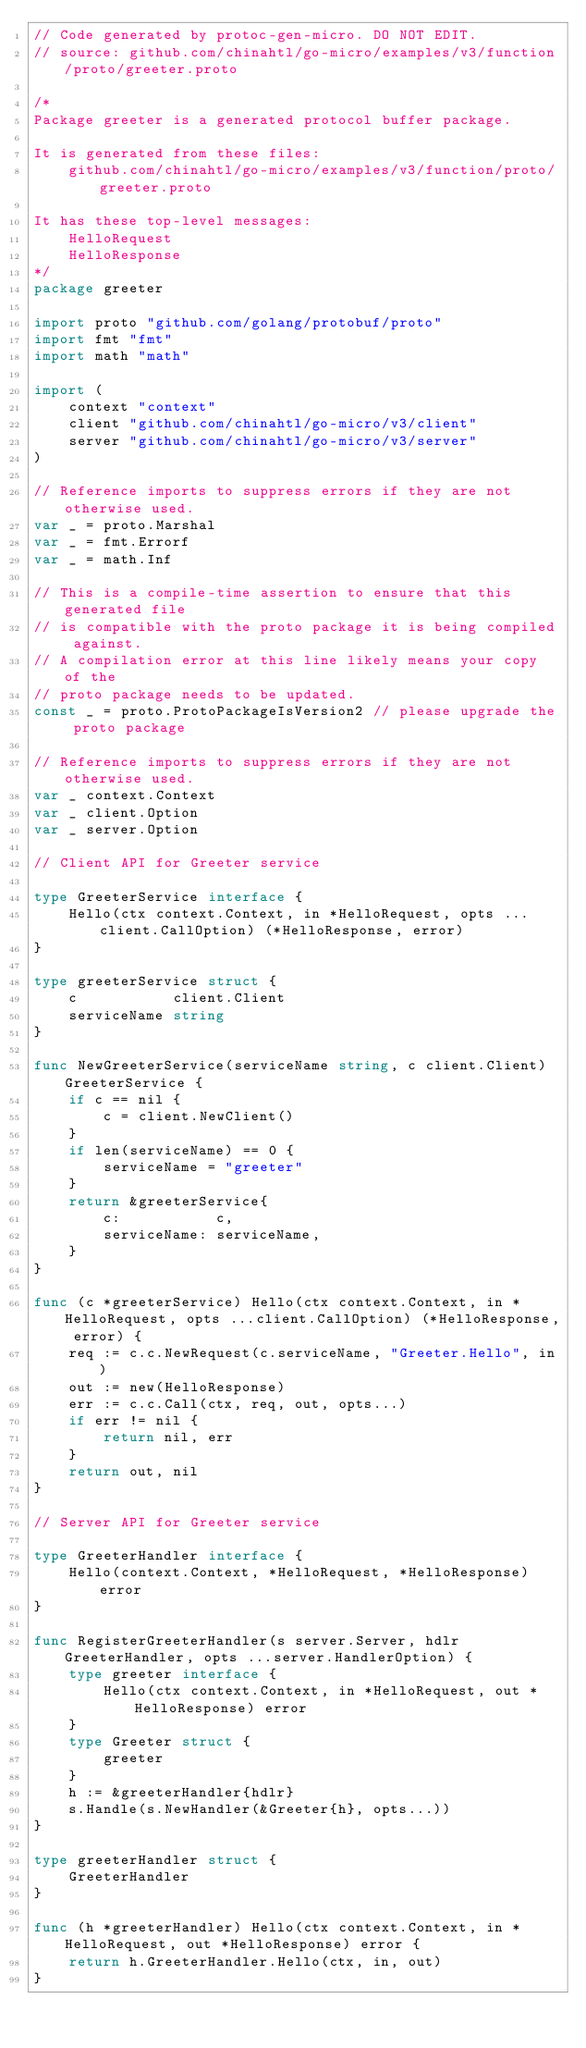Convert code to text. <code><loc_0><loc_0><loc_500><loc_500><_Go_>// Code generated by protoc-gen-micro. DO NOT EDIT.
// source: github.com/chinahtl/go-micro/examples/v3/function/proto/greeter.proto

/*
Package greeter is a generated protocol buffer package.

It is generated from these files:
	github.com/chinahtl/go-micro/examples/v3/function/proto/greeter.proto

It has these top-level messages:
	HelloRequest
	HelloResponse
*/
package greeter

import proto "github.com/golang/protobuf/proto"
import fmt "fmt"
import math "math"

import (
	context "context"
	client "github.com/chinahtl/go-micro/v3/client"
	server "github.com/chinahtl/go-micro/v3/server"
)

// Reference imports to suppress errors if they are not otherwise used.
var _ = proto.Marshal
var _ = fmt.Errorf
var _ = math.Inf

// This is a compile-time assertion to ensure that this generated file
// is compatible with the proto package it is being compiled against.
// A compilation error at this line likely means your copy of the
// proto package needs to be updated.
const _ = proto.ProtoPackageIsVersion2 // please upgrade the proto package

// Reference imports to suppress errors if they are not otherwise used.
var _ context.Context
var _ client.Option
var _ server.Option

// Client API for Greeter service

type GreeterService interface {
	Hello(ctx context.Context, in *HelloRequest, opts ...client.CallOption) (*HelloResponse, error)
}

type greeterService struct {
	c           client.Client
	serviceName string
}

func NewGreeterService(serviceName string, c client.Client) GreeterService {
	if c == nil {
		c = client.NewClient()
	}
	if len(serviceName) == 0 {
		serviceName = "greeter"
	}
	return &greeterService{
		c:           c,
		serviceName: serviceName,
	}
}

func (c *greeterService) Hello(ctx context.Context, in *HelloRequest, opts ...client.CallOption) (*HelloResponse, error) {
	req := c.c.NewRequest(c.serviceName, "Greeter.Hello", in)
	out := new(HelloResponse)
	err := c.c.Call(ctx, req, out, opts...)
	if err != nil {
		return nil, err
	}
	return out, nil
}

// Server API for Greeter service

type GreeterHandler interface {
	Hello(context.Context, *HelloRequest, *HelloResponse) error
}

func RegisterGreeterHandler(s server.Server, hdlr GreeterHandler, opts ...server.HandlerOption) {
	type greeter interface {
		Hello(ctx context.Context, in *HelloRequest, out *HelloResponse) error
	}
	type Greeter struct {
		greeter
	}
	h := &greeterHandler{hdlr}
	s.Handle(s.NewHandler(&Greeter{h}, opts...))
}

type greeterHandler struct {
	GreeterHandler
}

func (h *greeterHandler) Hello(ctx context.Context, in *HelloRequest, out *HelloResponse) error {
	return h.GreeterHandler.Hello(ctx, in, out)
}
</code> 